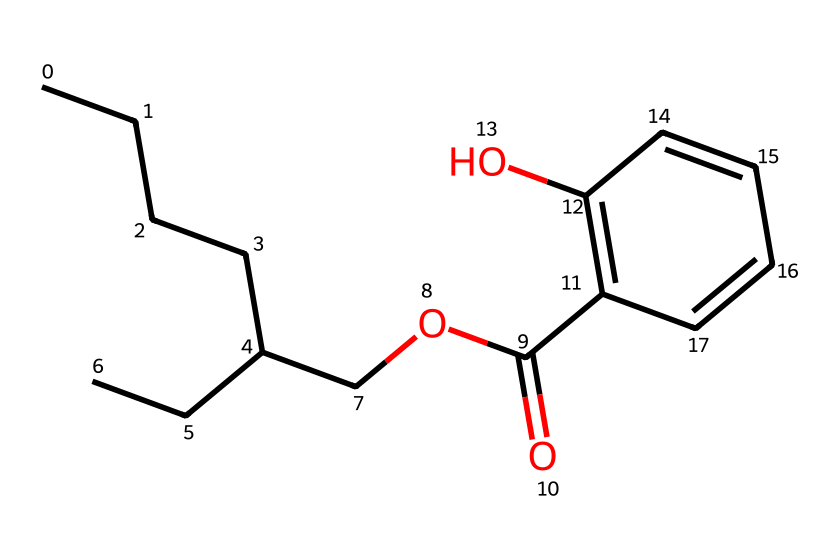How many carbon atoms are present in ethylhexyl salicylate? The chemical structure can be analyzed by counting the number of carbon atoms represented in the SMILES. In the provided structure, there are a total of 12 carbon atoms.
Answer: 12 What functional group is indicated by "COC(=O)" in the SMILES? The "COC(=O)" part of the SMILES indicates an ester functional group. The "C(=O)" suggests a carbonyl group bonded to an oxygen atom, which is characteristic of esters.
Answer: ester What is the primary characteristic of ethylhexyl salicylate as a cosmetic chemical? Ethylhexyl salicylate is primarily known as a UV absorber, which means it is used to protect against ultraviolet radiation in cosmetic formulations.
Answer: UV absorber How many double bonds can you identify in ethylhexyl salicylate? In the SMILES representation, the presence of double bonds can be identified by looking for "=" signs. There are two double bonds in the ring structure indicated by "C1=C(O)C=CC."
Answer: 2 What type of chemical reaction could ethylhexyl salicylate undergo in solution? As an ester, ethylhexyl salicylate can undergo hydrolysis in the presence of water, especially under acidic or basic conditions, leading to the formation of salicylic acid and an alcohol.
Answer: hydrolysis Is ethylhexyl salicylate considered hydrophobic or hydrophilic? Given its long hydrocarbon chain and the ester functional group, ethylhexyl salicylate exhibits a largely hydrophobic character, making it insoluble in water.
Answer: hydrophobic 